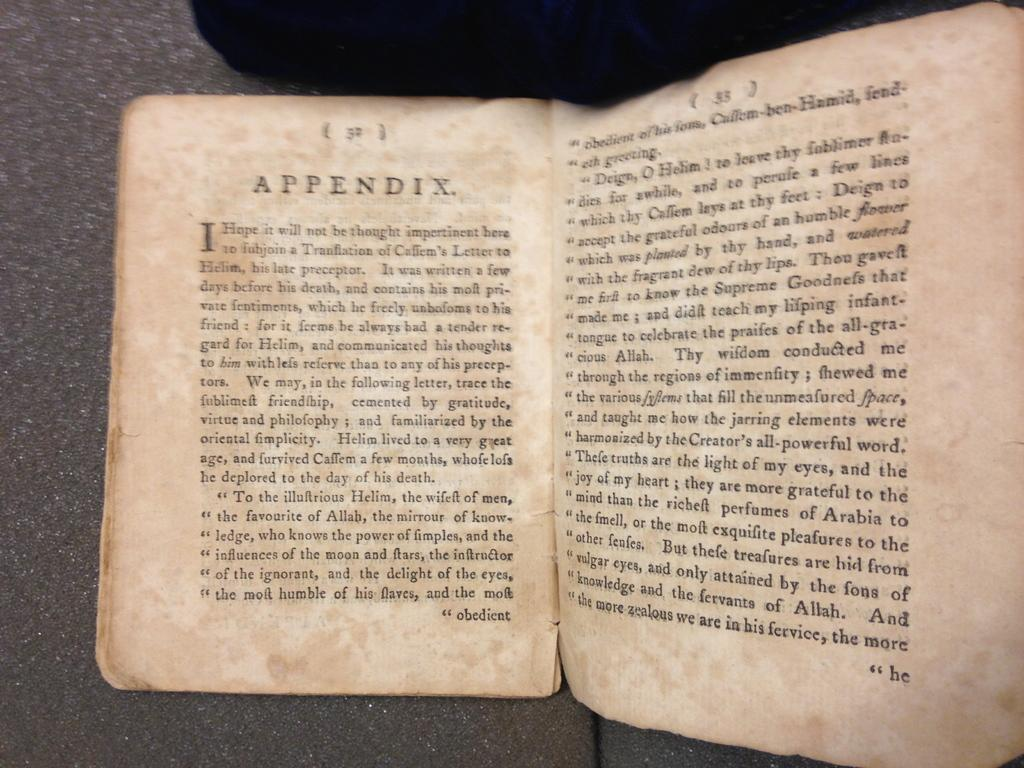<image>
Render a clear and concise summary of the photo. The book is open to the beginning of the Appendix section. 